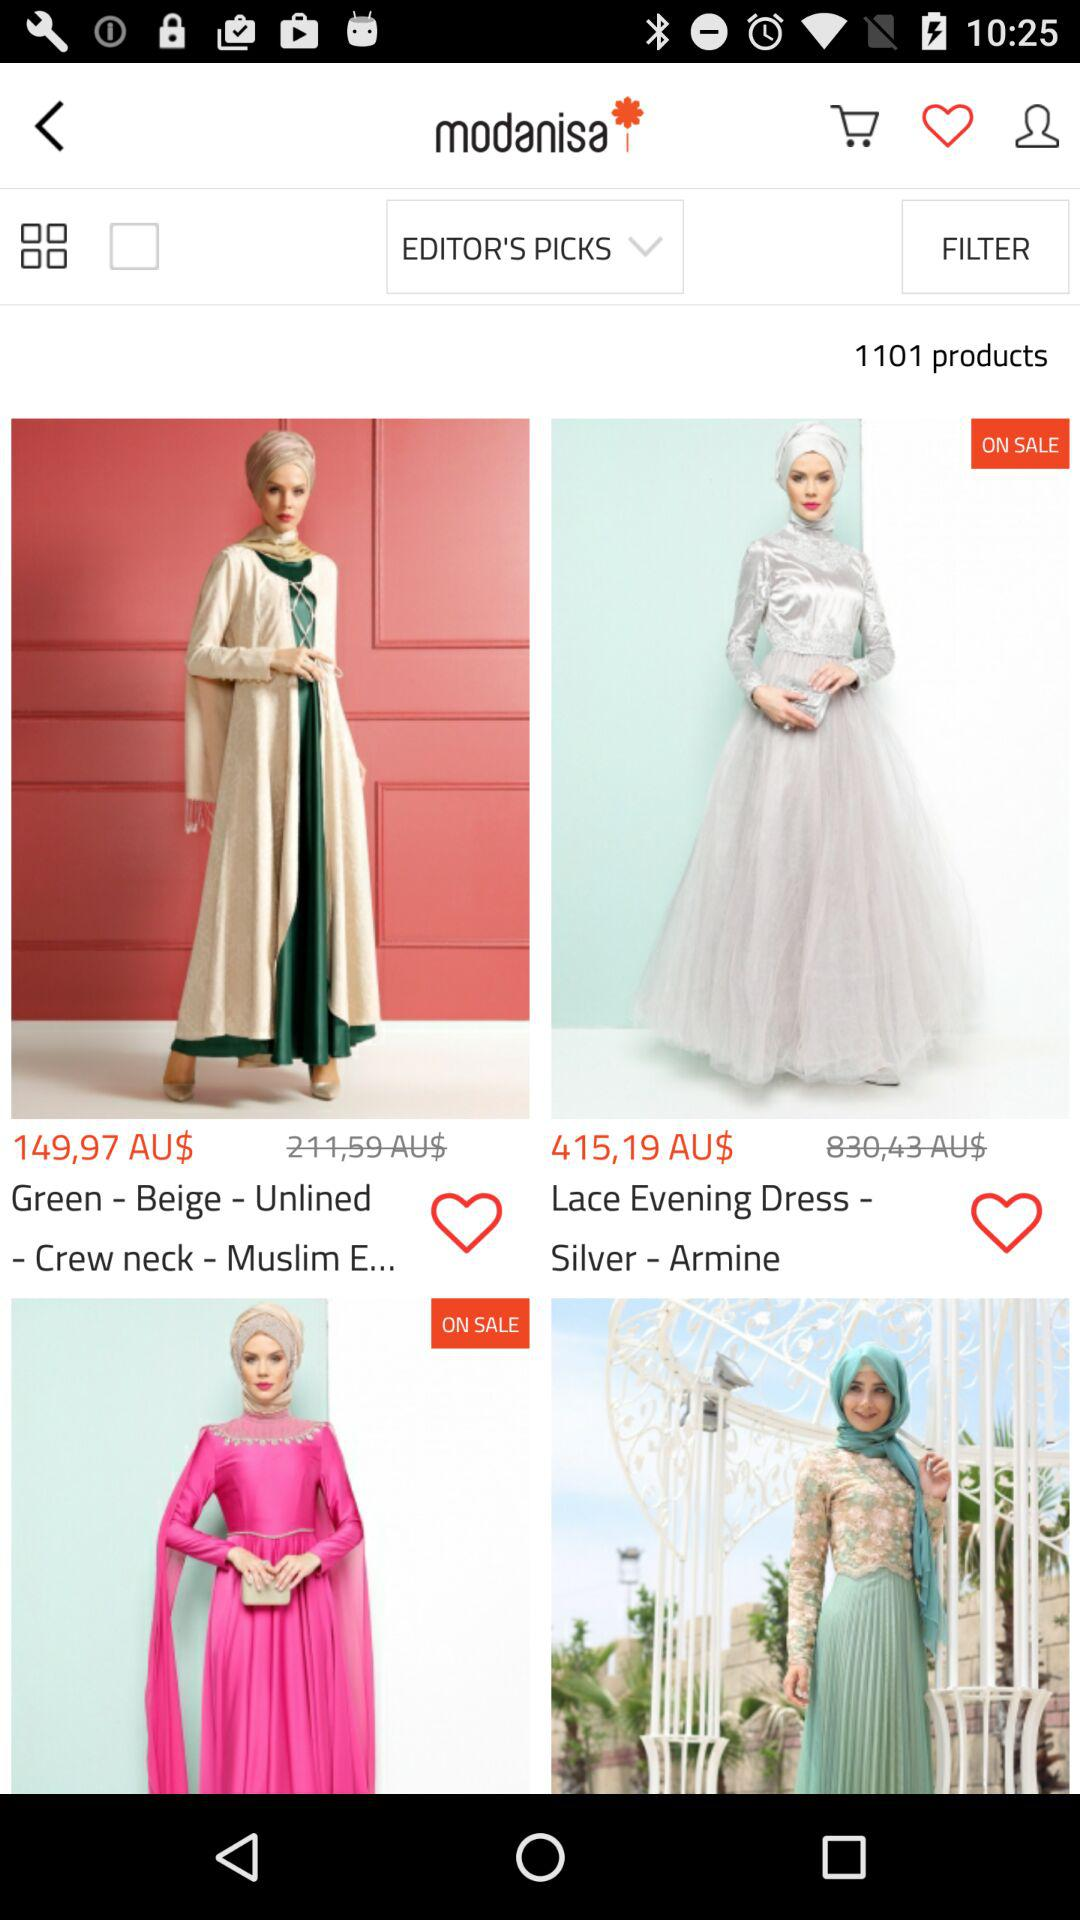What is the total number of products? The total number of products is 1101. 